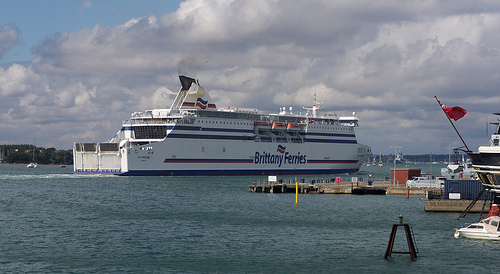Please provide the bounding box coordinate of the region this sentence describes: Brittany Ferries on the side of the ship. The bounding box coordinates for the text 'Brittany Ferries' on the side of the ship are [0.5, 0.5, 0.64, 0.56]. 